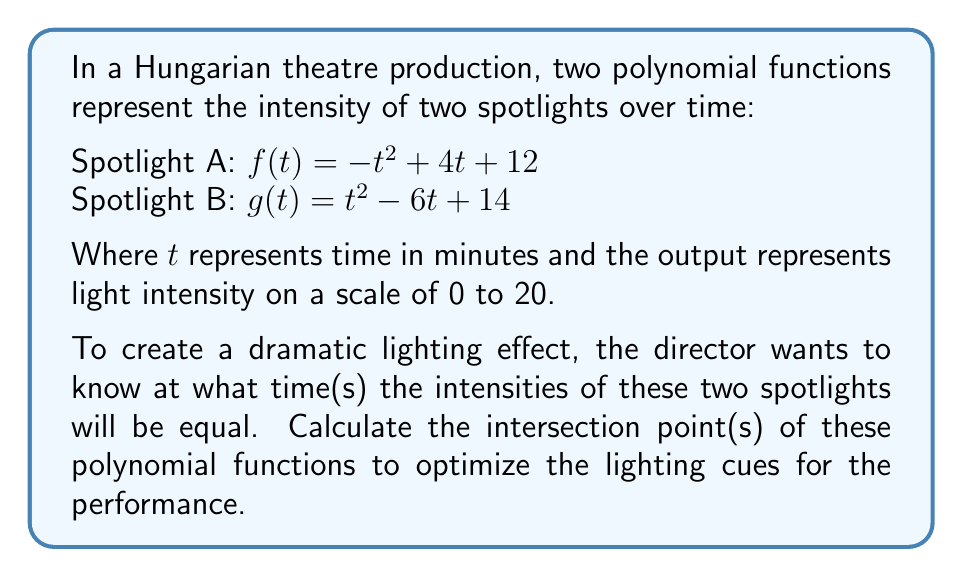What is the answer to this math problem? To find the intersection points of the two polynomial functions, we need to set them equal to each other and solve for $t$:

$f(t) = g(t)$
$-t^2 + 4t + 12 = t^2 - 6t + 14$

Rearranging the equation:
$-t^2 + 4t + 12 - (t^2 - 6t + 14) = 0$
$-2t^2 + 10t - 2 = 0$

Dividing everything by -2:
$t^2 - 5t + 1 = 0$

This is a quadratic equation in the standard form $at^2 + bt + c = 0$, where $a=1$, $b=-5$, and $c=1$.

We can solve this using the quadratic formula: $t = \frac{-b \pm \sqrt{b^2 - 4ac}}{2a}$

Substituting our values:
$t = \frac{5 \pm \sqrt{(-5)^2 - 4(1)(1)}}{2(1)}$
$t = \frac{5 \pm \sqrt{25 - 4}}{2}$
$t = \frac{5 \pm \sqrt{21}}{2}$

This gives us two solutions:
$t_1 = \frac{5 + \sqrt{21}}{2} \approx 4.79$ minutes
$t_2 = \frac{5 - \sqrt{21}}{2} \approx 0.21$ minutes

To verify, we can substitute these values back into our original functions:

For $t_1 \approx 4.79$:
$f(4.79) \approx 15.99$
$g(4.79) \approx 15.99$

For $t_2 \approx 0.21$:
$f(0.21) \approx 12.83$
$g(0.21) \approx 12.83$

These results confirm that our calculated intersection points are correct.
Answer: The spotlights will have equal intensity at approximately 0.21 minutes and 4.79 minutes into the performance. The lighting cues should be optimized for these two specific times to create the desired dramatic effect. 